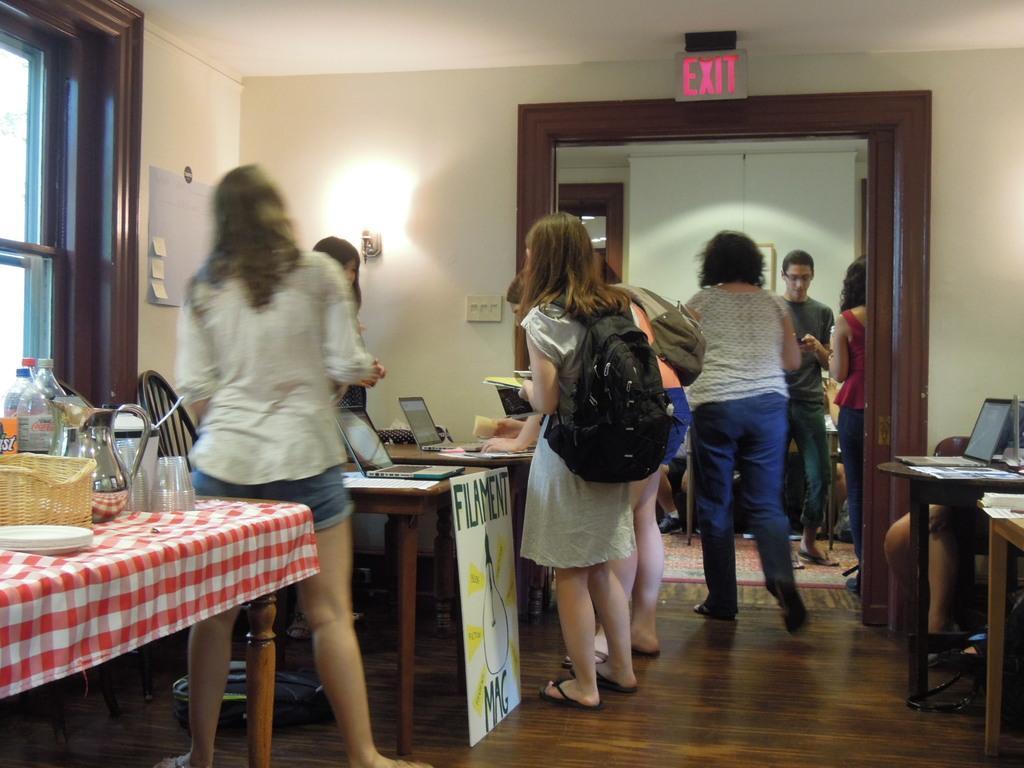Can you describe this image briefly? There are many people standing in this room. A woman is wearing a bag holding a book and standing. In front of them there are many tables. On the table there are laptops, glasses, bottles, baskets, jugs and many other items. There is a EXIT board on the ceiling. There are switches and lights on the wall. On the left side there is a window. Also a board with notices. 